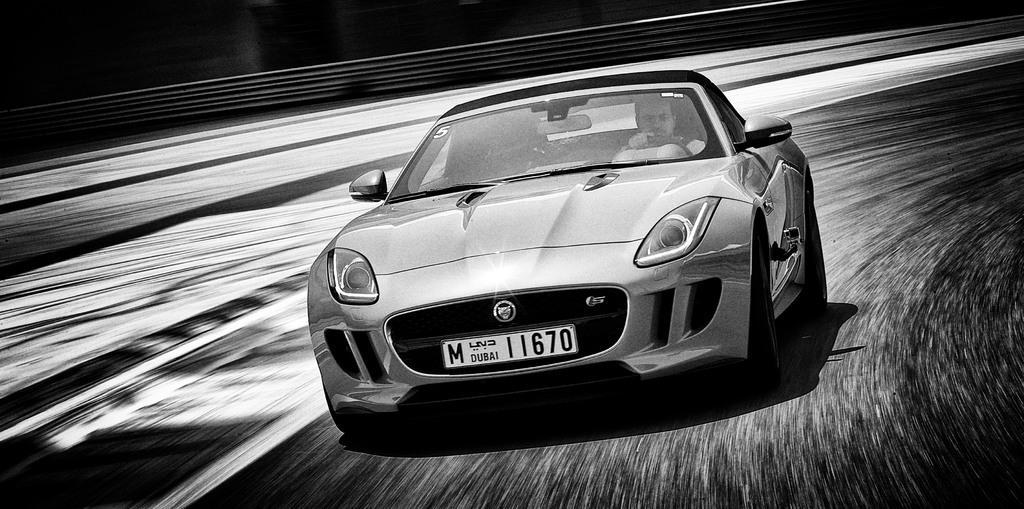In one or two sentences, can you explain what this image depicts? In the picture I can see a man riding a car on the road. It is looking like a fence at the top of the picture. 